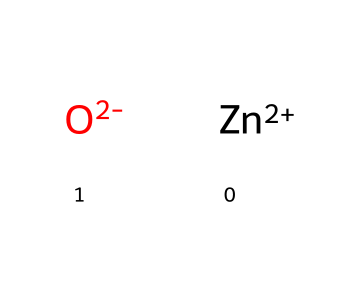What elements are present in zinc oxide? The SMILES representation shows two main components: [Zn+2] indicating the presence of zinc, and [O-2] indicating the presence of oxygen. Therefore, zinc oxide contains zinc and oxygen.
Answer: zinc and oxygen How many atoms are in zinc oxide? The SMILES representation indicates one zinc atom ([Zn+2]) and one oxygen atom ([O-2]), leading to a total of two atoms in zinc oxide.
Answer: two What is the charge of the zinc atom in zinc oxide? In the SMILES notation, [Zn+2] indicates that the zinc atom has a +2 charge.
Answer: +2 What type of compound is zinc oxide? Zinc oxide is classified as an inorganic compound due to its metal and non-metal composition without carbon-hydrogen bonds.
Answer: inorganic Why is zinc oxide used in sunscreens? Zinc oxide provides broad-spectrum UV protection, an important quality for sunscreens, as it effectively absorbs and reflects UV radiation. The structure, with its ionic nature, contributes to its effectiveness in blocking UV rays.
Answer: UV protection What type of bonding is present in zinc oxide? The interactions in zinc oxide are ionic, as indicated by the presence of charged ions ([Zn+2] and [O-2]), which are held together by electrostatic forces.
Answer: ionic 